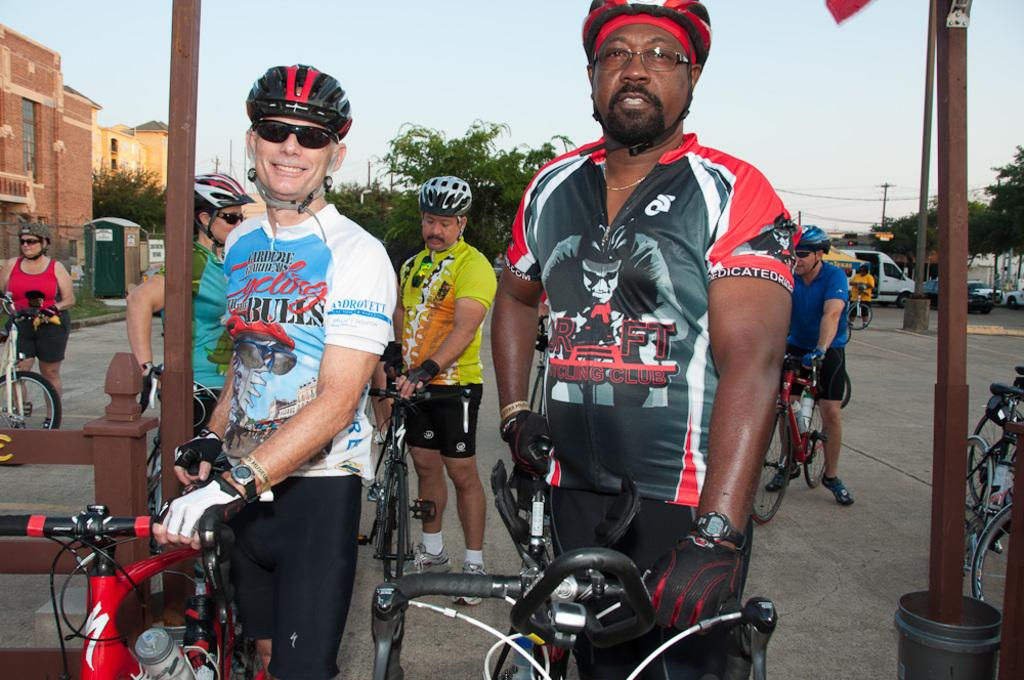What are the men in the image holding? The men in the image are holding bicycles. What can be seen in the background of the image? There is a road, a pole, a tree, a building, and the sky visible in the background of the image. What type of plant is the duck sitting on in the image? There is no plant or duck present in the image. Is there a house visible in the image? The provided facts do not mention a house, so we cannot definitively say whether a house is visible in the image or not. 